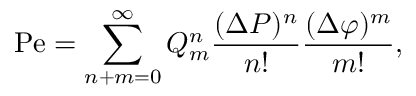<formula> <loc_0><loc_0><loc_500><loc_500>P e = \sum _ { n + m = 0 } ^ { \infty } Q _ { m } ^ { n } \frac { ( \Delta P ) ^ { n } } { n ! } \frac { ( \Delta \varphi ) ^ { m } } { m ! } ,</formula> 